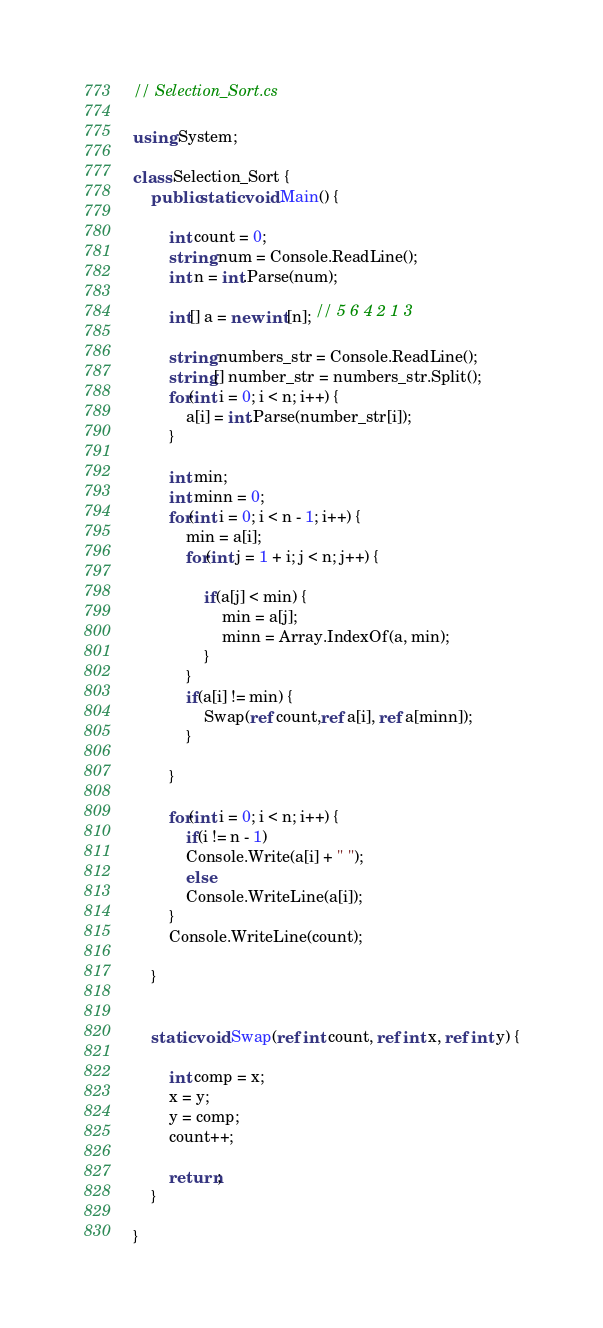Convert code to text. <code><loc_0><loc_0><loc_500><loc_500><_C#_>// Selection_Sort.cs

using System;

class Selection_Sort {
	public static void Main() {

		int count = 0;
		string num = Console.ReadLine();
		int n = int.Parse(num);

		int[] a = new int[n]; // 5 6 4 2 1 3 

		string numbers_str = Console.ReadLine();
		string[] number_str = numbers_str.Split();
		for(int i = 0; i < n; i++) {
			a[i] = int.Parse(number_str[i]);
		}

		int min;
		int minn = 0;
		for(int i = 0; i < n - 1; i++) {
			min = a[i];
			for(int j = 1 + i; j < n; j++) {

				if(a[j] < min) {
					min = a[j];
					minn = Array.IndexOf(a, min);
				}
			}
			if(a[i] != min) {
				Swap(ref count,ref a[i], ref a[minn]);
			}

		}

		for(int i = 0; i < n; i++) {
			if(i != n - 1)
			Console.Write(a[i] + " ");
			else
			Console.WriteLine(a[i]);
		}
		Console.WriteLine(count);

	}


	static void Swap(ref int count, ref int x, ref int y) {

		int comp = x;
		x = y;
		y = comp;
		count++;

		return;
	}

}</code> 